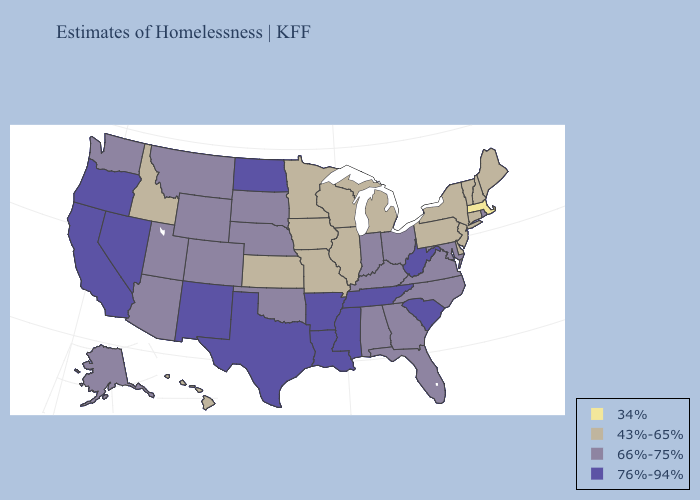What is the value of Idaho?
Give a very brief answer. 43%-65%. Name the states that have a value in the range 76%-94%?
Write a very short answer. Arkansas, California, Louisiana, Mississippi, Nevada, New Mexico, North Dakota, Oregon, South Carolina, Tennessee, Texas, West Virginia. Does Nevada have the same value as Virginia?
Keep it brief. No. Among the states that border Utah , does Arizona have the lowest value?
Be succinct. No. What is the lowest value in the MidWest?
Answer briefly. 43%-65%. What is the value of Wisconsin?
Short answer required. 43%-65%. What is the lowest value in the USA?
Answer briefly. 34%. Among the states that border Kansas , which have the lowest value?
Answer briefly. Missouri. Does Mississippi have a higher value than Wisconsin?
Keep it brief. Yes. What is the highest value in states that border Pennsylvania?
Give a very brief answer. 76%-94%. Does the map have missing data?
Give a very brief answer. No. Name the states that have a value in the range 43%-65%?
Keep it brief. Connecticut, Delaware, Hawaii, Idaho, Illinois, Iowa, Kansas, Maine, Michigan, Minnesota, Missouri, New Hampshire, New Jersey, New York, Pennsylvania, Vermont, Wisconsin. Does Virginia have a lower value than Oregon?
Quick response, please. Yes. Name the states that have a value in the range 43%-65%?
Answer briefly. Connecticut, Delaware, Hawaii, Idaho, Illinois, Iowa, Kansas, Maine, Michigan, Minnesota, Missouri, New Hampshire, New Jersey, New York, Pennsylvania, Vermont, Wisconsin. What is the value of Washington?
Answer briefly. 66%-75%. 